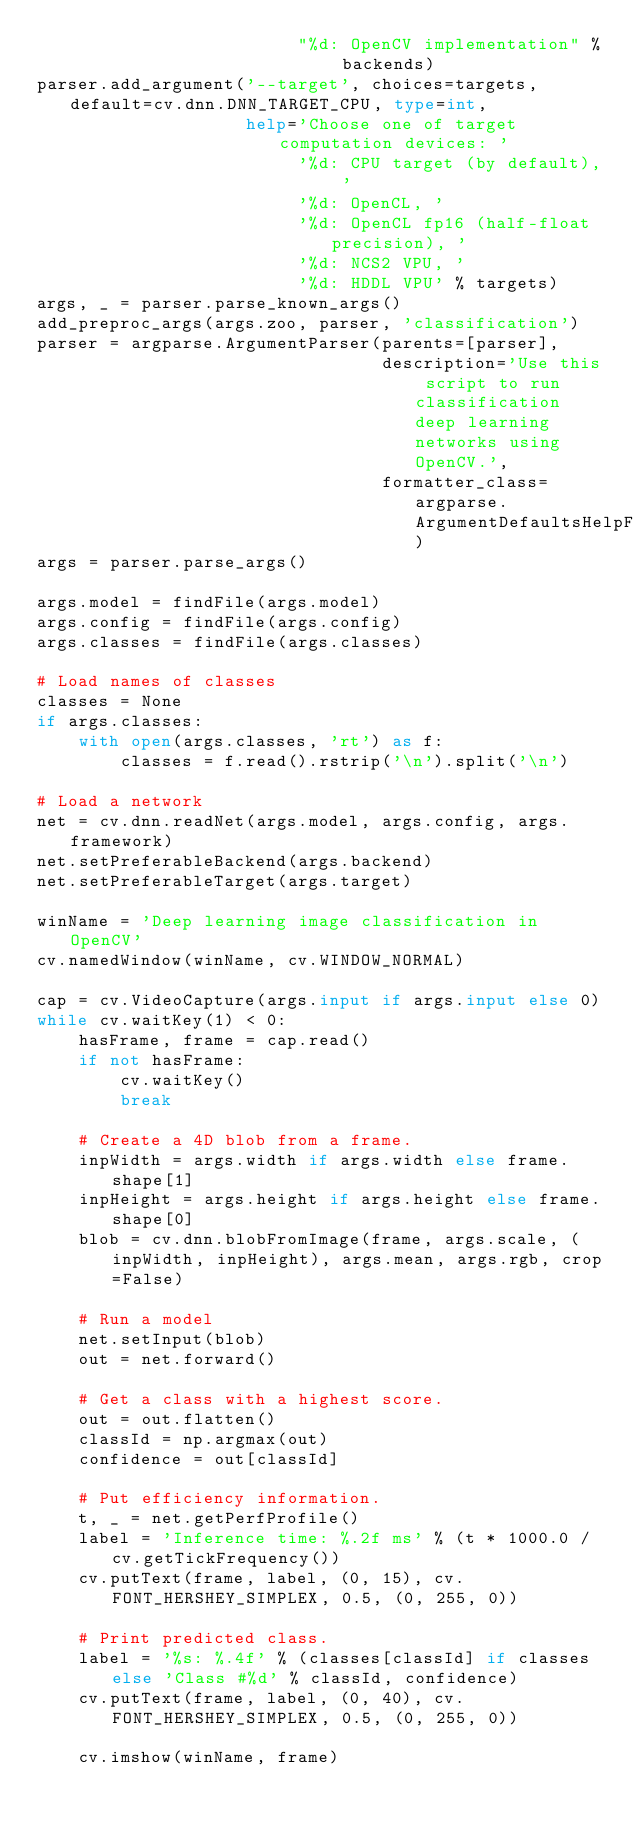<code> <loc_0><loc_0><loc_500><loc_500><_Python_>                         "%d: OpenCV implementation" % backends)
parser.add_argument('--target', choices=targets, default=cv.dnn.DNN_TARGET_CPU, type=int,
                    help='Choose one of target computation devices: '
                         '%d: CPU target (by default), '
                         '%d: OpenCL, '
                         '%d: OpenCL fp16 (half-float precision), '
                         '%d: NCS2 VPU, '
                         '%d: HDDL VPU' % targets)
args, _ = parser.parse_known_args()
add_preproc_args(args.zoo, parser, 'classification')
parser = argparse.ArgumentParser(parents=[parser],
                                 description='Use this script to run classification deep learning networks using OpenCV.',
                                 formatter_class=argparse.ArgumentDefaultsHelpFormatter)
args = parser.parse_args()

args.model = findFile(args.model)
args.config = findFile(args.config)
args.classes = findFile(args.classes)

# Load names of classes
classes = None
if args.classes:
    with open(args.classes, 'rt') as f:
        classes = f.read().rstrip('\n').split('\n')

# Load a network
net = cv.dnn.readNet(args.model, args.config, args.framework)
net.setPreferableBackend(args.backend)
net.setPreferableTarget(args.target)

winName = 'Deep learning image classification in OpenCV'
cv.namedWindow(winName, cv.WINDOW_NORMAL)

cap = cv.VideoCapture(args.input if args.input else 0)
while cv.waitKey(1) < 0:
    hasFrame, frame = cap.read()
    if not hasFrame:
        cv.waitKey()
        break

    # Create a 4D blob from a frame.
    inpWidth = args.width if args.width else frame.shape[1]
    inpHeight = args.height if args.height else frame.shape[0]
    blob = cv.dnn.blobFromImage(frame, args.scale, (inpWidth, inpHeight), args.mean, args.rgb, crop=False)

    # Run a model
    net.setInput(blob)
    out = net.forward()

    # Get a class with a highest score.
    out = out.flatten()
    classId = np.argmax(out)
    confidence = out[classId]

    # Put efficiency information.
    t, _ = net.getPerfProfile()
    label = 'Inference time: %.2f ms' % (t * 1000.0 / cv.getTickFrequency())
    cv.putText(frame, label, (0, 15), cv.FONT_HERSHEY_SIMPLEX, 0.5, (0, 255, 0))

    # Print predicted class.
    label = '%s: %.4f' % (classes[classId] if classes else 'Class #%d' % classId, confidence)
    cv.putText(frame, label, (0, 40), cv.FONT_HERSHEY_SIMPLEX, 0.5, (0, 255, 0))

    cv.imshow(winName, frame)
</code> 